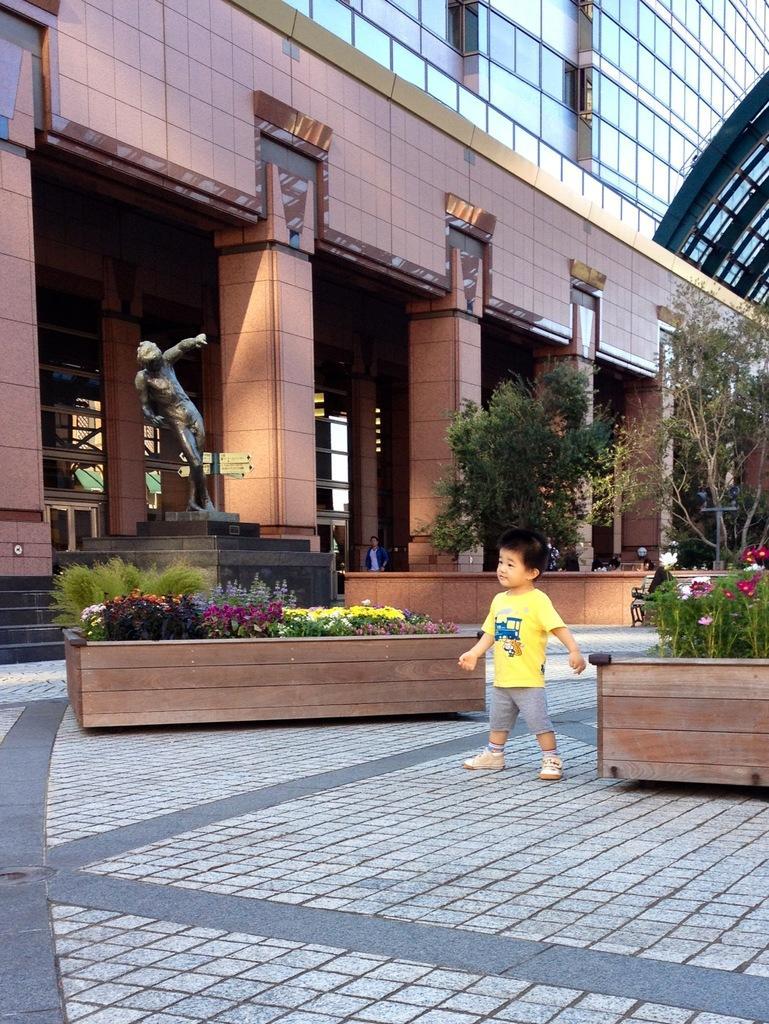How would you summarize this image in a sentence or two? At the center of the image there is a little boy standing, on the either sides of the boy there are plants. In the background there is a building, in front of the building there is a statue and trees. 